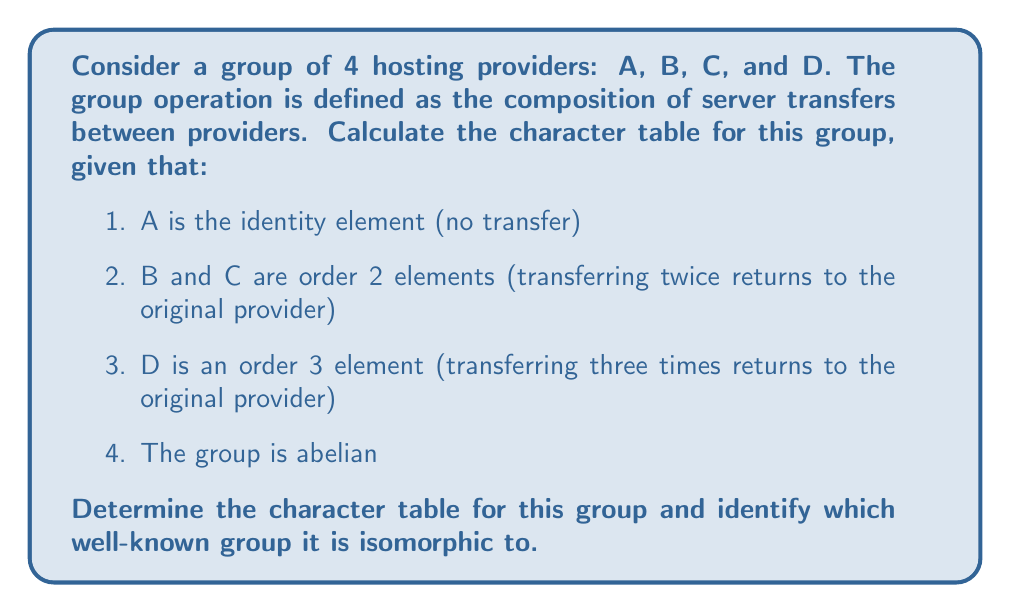What is the answer to this math problem? To calculate the character table, we'll follow these steps:

1. Identify the group structure:
   The group has 4 elements: $\{A, B, C, D\}$
   $A$ is the identity, $B^2 = C^2 = A$, $D^3 = A$
   The group is abelian, so all elements commute

2. Determine the conjugacy classes:
   Since the group is abelian, each element forms its own conjugacy class:
   $\{A\}, \{B\}, \{C\}, \{D\}$

3. Identify the number of irreducible representations:
   The number of irreducible representations is equal to the number of conjugacy classes, which is 4

4. Determine the dimensions of irreducible representations:
   For an abelian group, all irreducible representations are 1-dimensional

5. Construct the character table:
   - The first row is always 1 for all elements (trivial representation)
   - For the remaining rows, we need to find 3 more 1-dimensional representations
   - Since $B^2 = C^2 = A$, their character values must be either 1 or -1
   - Since $D^3 = A$, its character values must be 1, $\omega$, or $\omega^2$, where $\omega = e^{2\pi i/3}$

   The character table will have the following structure:
   $$
   \begin{array}{c|cccc}
     & A & B & C & D \\
   \hline
   \chi_1 & 1 & 1 & 1 & 1 \\
   \chi_2 & 1 & -1 & 1 & \omega \\
   \chi_3 & 1 & 1 & -1 & \omega^2 \\
   \chi_4 & 1 & -1 & -1 & 1
   \end{array}
   $$

6. Verify orthogonality relations:
   The columns and rows of the character table should be orthogonal, which can be easily verified

7. Identify the group:
   This character table corresponds to the group $C_2 \times C_2 \times C_3$, which is isomorphic to $C_6 \times C_2$
Answer: Character table:
$$
\begin{array}{c|cccc}
  & A & B & C & D \\
\hline
\chi_1 & 1 & 1 & 1 & 1 \\
\chi_2 & 1 & -1 & 1 & \omega \\
\chi_3 & 1 & 1 & -1 & \omega^2 \\
\chi_4 & 1 & -1 & -1 & 1
\end{array}
$$
where $\omega = e^{2\pi i/3}$. Group is isomorphic to $C_6 \times C_2$. 